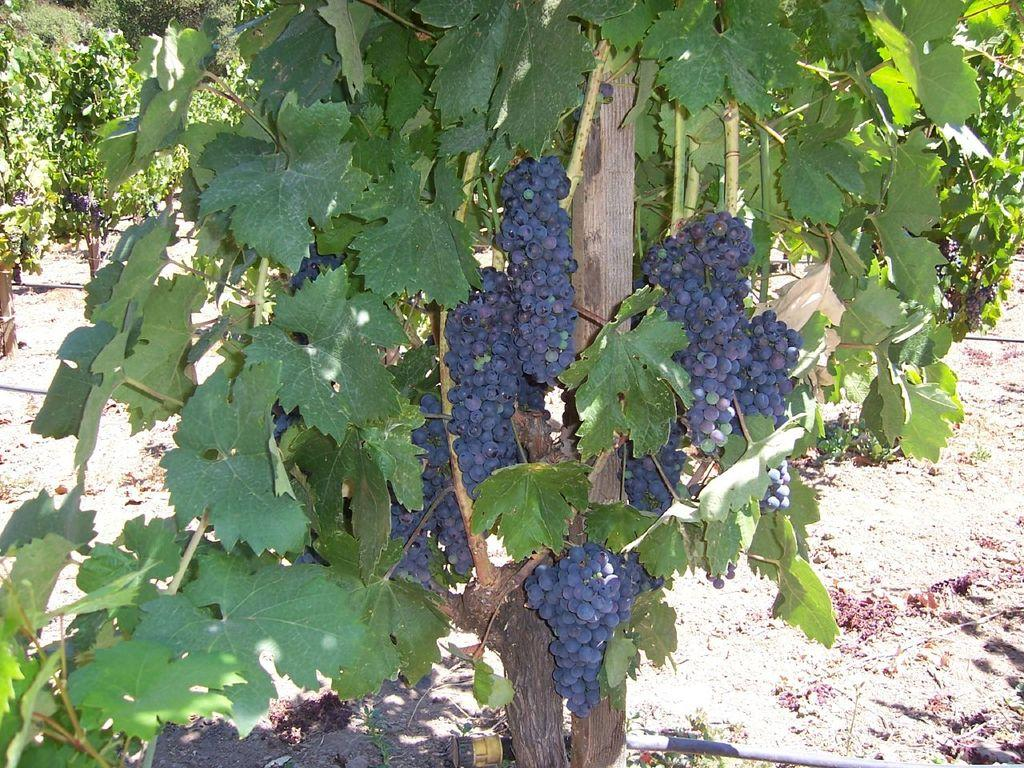What type of vegetation is present in the image? There are trees in the image. What type of fruit can be seen in the image? There are blueberries in the image. What color is the prominent object in the image? There is a yellow object in the image. What type of thrill can be experienced while looking at the sky in the image? The image does not depict a sky, nor does it suggest any thrilling experiences. 